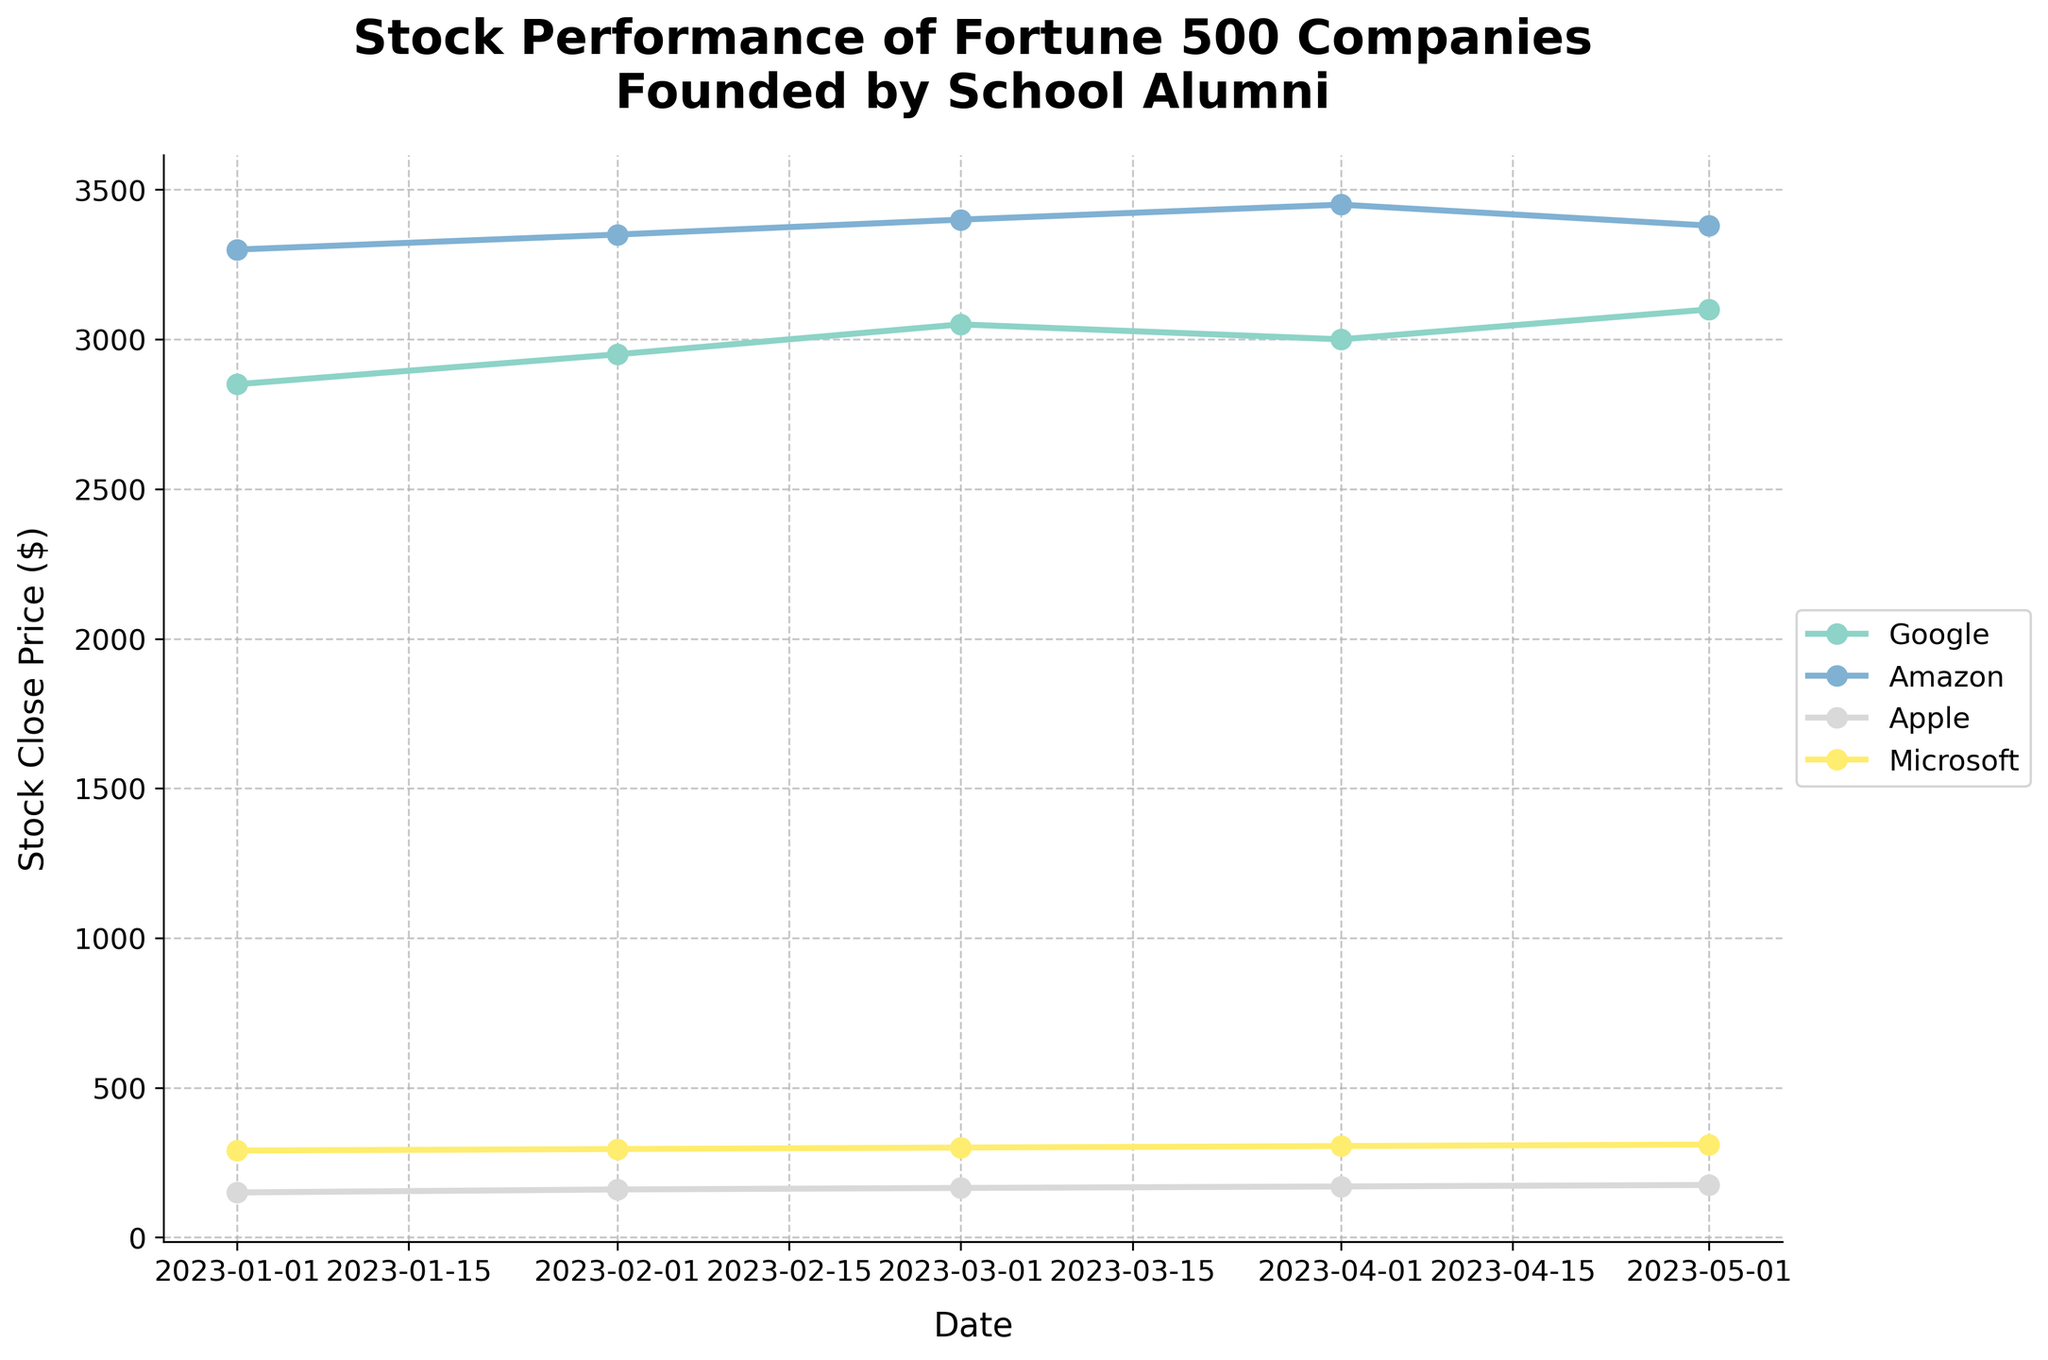Which company's stock price showed the highest absolute increase from January to May 2023? The stock prices for each month can be traced along the lines for each company. Calculate the absolute increase for each one: 
- Google: \(3100 - 2850 = 250\)
- Amazon: \(3380 - 3300 = 80\)
- Apple: \(175 - 150 = 25\)
- Microsoft: \(310 - 290 = 20\). Among these, Google has the highest increase.
Answer: Google Which company had the most stable stock price between January and May 2023? Stability in stock price is indicated by the smallest variance in the price over time. Here, any sharp changes or fluctuations in the curves can be identified visually. Microsoft's stock price changes the least.
Answer: Microsoft Which company had the highest stock close price in January 2023? By noting the first data point for each company (January 2023 value): Google (2850), Amazon (3300), Apple (150), and Microsoft (290), it's clear that Amazon had the highest price.
Answer: Amazon Between April and May 2023, which company's stock price decreased? Compare the stock prices between April and May for each company. Google: \(3100-3000=100\) (increase), Amazon: \(3380-3450=-70\) (decrease), Apple: \(175-170=5\) (increase), Microsoft: \(310-305=5\) (increase). Hence, Amazon's price decreased.
Answer: Amazon What's the average closing price of Google's stock over the five months displayed? Sum up the closing prices for Google (2850 + 2950 + 3050 + 3000 + 3100) and divide by 5: \(\frac{2850 + 2950 + 3050 + 3000 + 3100}{5} = 2990\).
Answer: 2990 Comparing Apple and Microsoft, which company experienced a larger percentage increase from January to May 2023? Calculate the percentage increase for both companies from January to May. 
- Apple: \(\frac{(175 - 150)}{150} \times 100 = 16.67\%\)
- Microsoft: \(\frac{(310 - 290)}{290} \times 100 = 6.90\%\). Hence, Apple experienced a larger percentage increase.
Answer: Apple Between February and March 2023, by how much did Amazon's stock price increase? Identify the prices for Amazon in February (3350) and March (3400) and then subtract: \(3400 - 3350 = 50\).
Answer: 50 Did any company's stock price end lower in May 2023 compared to any point earlier in the year? Check the end prices in May for each company and compare with earlier months. None of the companies have a May closing price lower than their starting points in January.
Answer: No Comparing the trend lines, which company's stock price initially increased but then decreased before May 2023? Analyze the trend lines for each company. Google's line rises until March then slightly decreases in April before rising again. Thus, it exhibited an increase followed by a decrease.
Answer: Google 